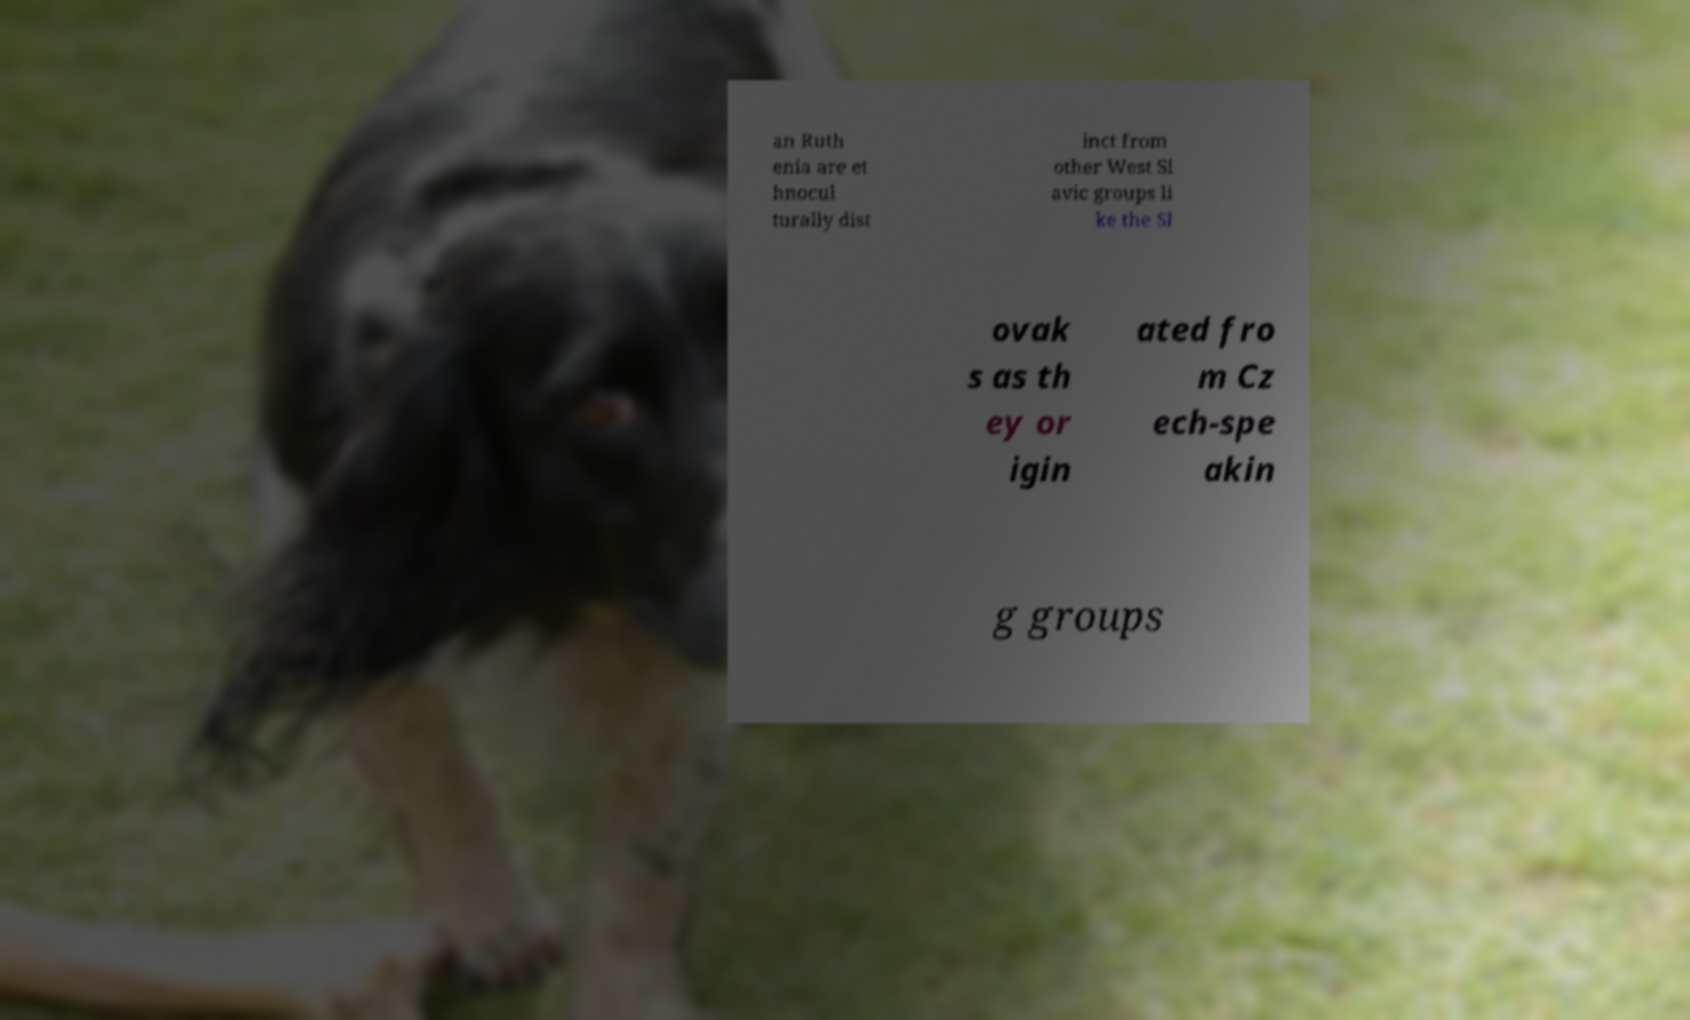For documentation purposes, I need the text within this image transcribed. Could you provide that? an Ruth enia are et hnocul turally dist inct from other West Sl avic groups li ke the Sl ovak s as th ey or igin ated fro m Cz ech-spe akin g groups 